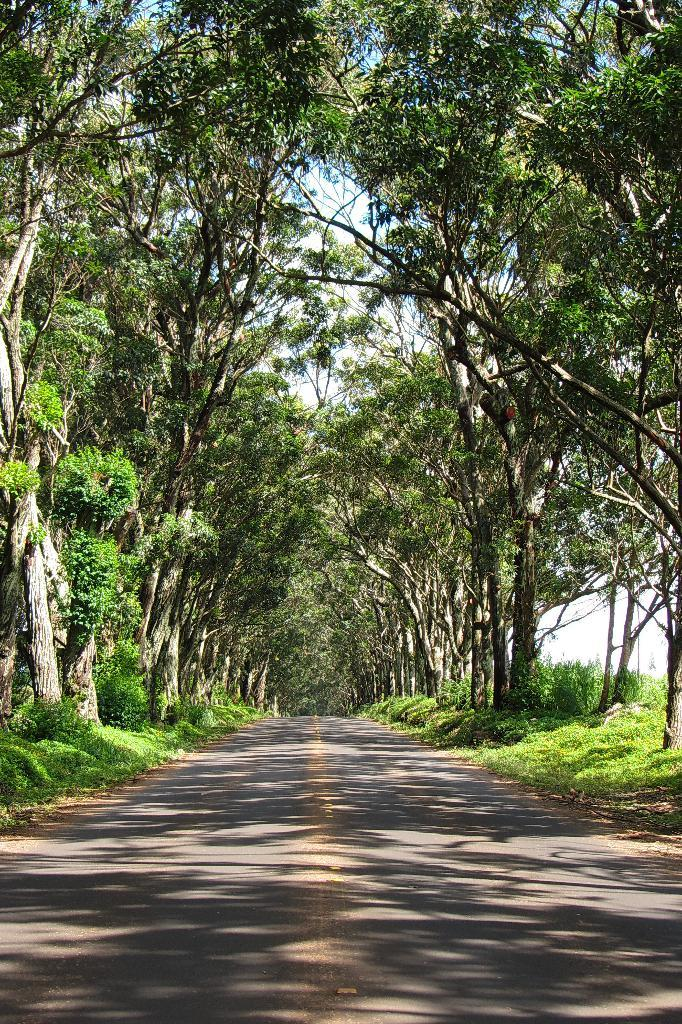Where was the picture taken? The picture was clicked outside. What can be seen in the foreground of the image? There is a road in the foreground of the image. What type of vegetation is present on both sides of the road? There is green grass and plants on both sides of the road. What other natural elements can be seen on both sides of the road? There are trees on both sides of the road. What is visible in the background of the image? The sky is visible in the background of the image. What type of wood is used to make the quiver in the image? There is no quiver present in the image, so it is not possible to determine what type of wood might be used. 